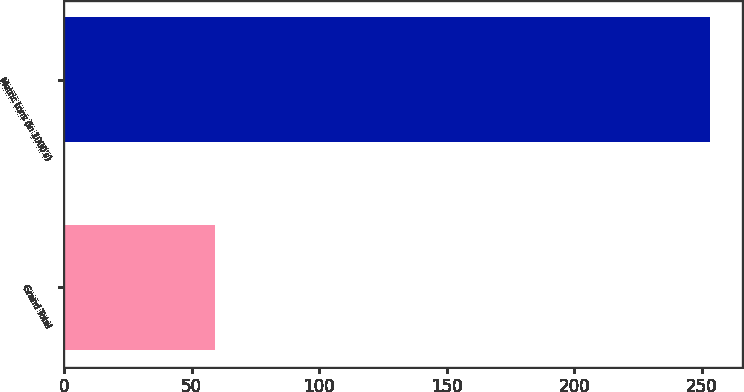Convert chart. <chart><loc_0><loc_0><loc_500><loc_500><bar_chart><fcel>Grand Total<fcel>Metric tons (in 1000's)<nl><fcel>59<fcel>253<nl></chart> 